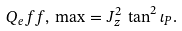<formula> <loc_0><loc_0><loc_500><loc_500>Q _ { e } f f , \, \max = J _ { z } ^ { 2 } \, \tan ^ { 2 } \iota _ { P } .</formula> 